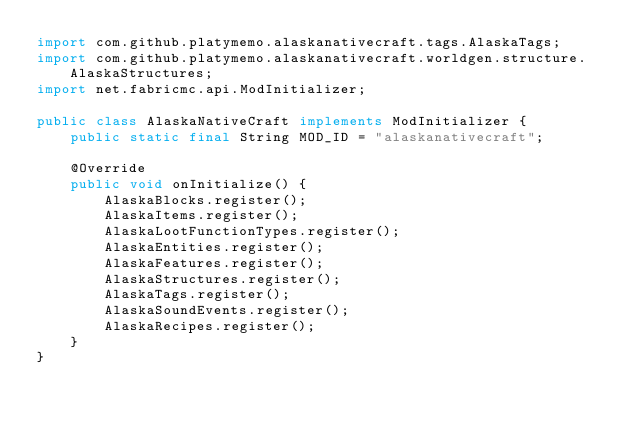Convert code to text. <code><loc_0><loc_0><loc_500><loc_500><_Java_>import com.github.platymemo.alaskanativecraft.tags.AlaskaTags;
import com.github.platymemo.alaskanativecraft.worldgen.structure.AlaskaStructures;
import net.fabricmc.api.ModInitializer;

public class AlaskaNativeCraft implements ModInitializer {
    public static final String MOD_ID = "alaskanativecraft";

    @Override
    public void onInitialize() {
        AlaskaBlocks.register();
        AlaskaItems.register();
        AlaskaLootFunctionTypes.register();
        AlaskaEntities.register();
        AlaskaFeatures.register();
        AlaskaStructures.register();
        AlaskaTags.register();
        AlaskaSoundEvents.register();
        AlaskaRecipes.register();
    }
}
</code> 